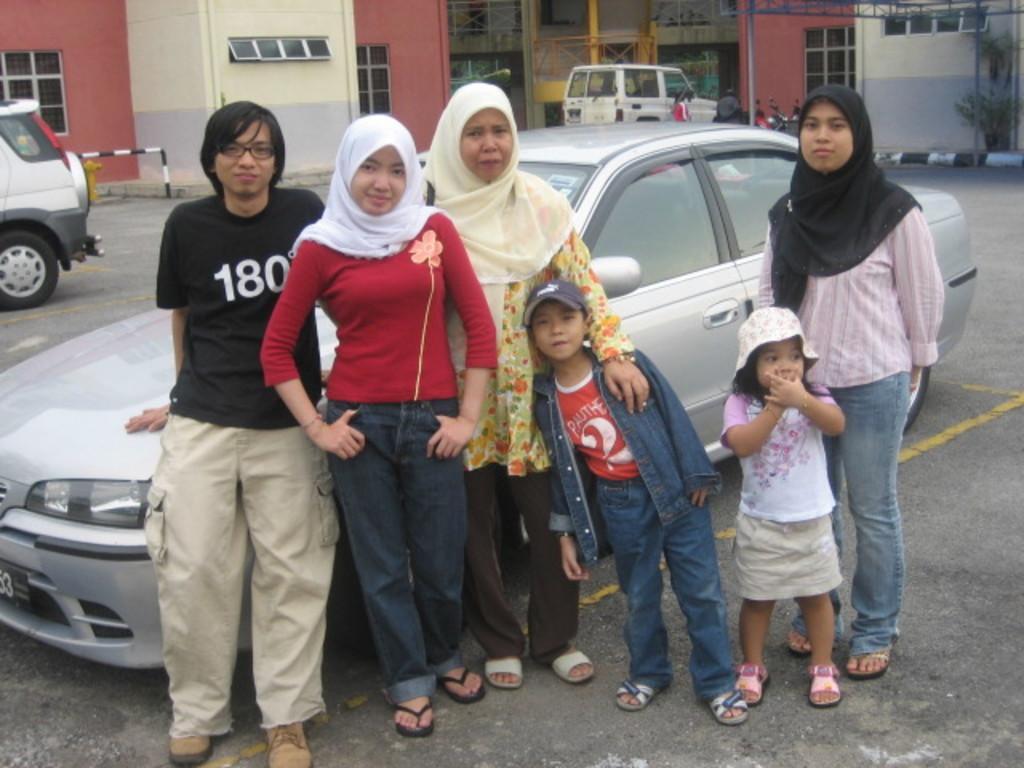Can you describe this image briefly? In the center of the image we can see many persons standing on the road. In the background we can see cars, vehicles, plants and building. 